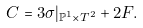<formula> <loc_0><loc_0><loc_500><loc_500>C = 3 \sigma | _ { { \mathbb { P } } ^ { 1 } \times T ^ { 2 } } + 2 F .</formula> 